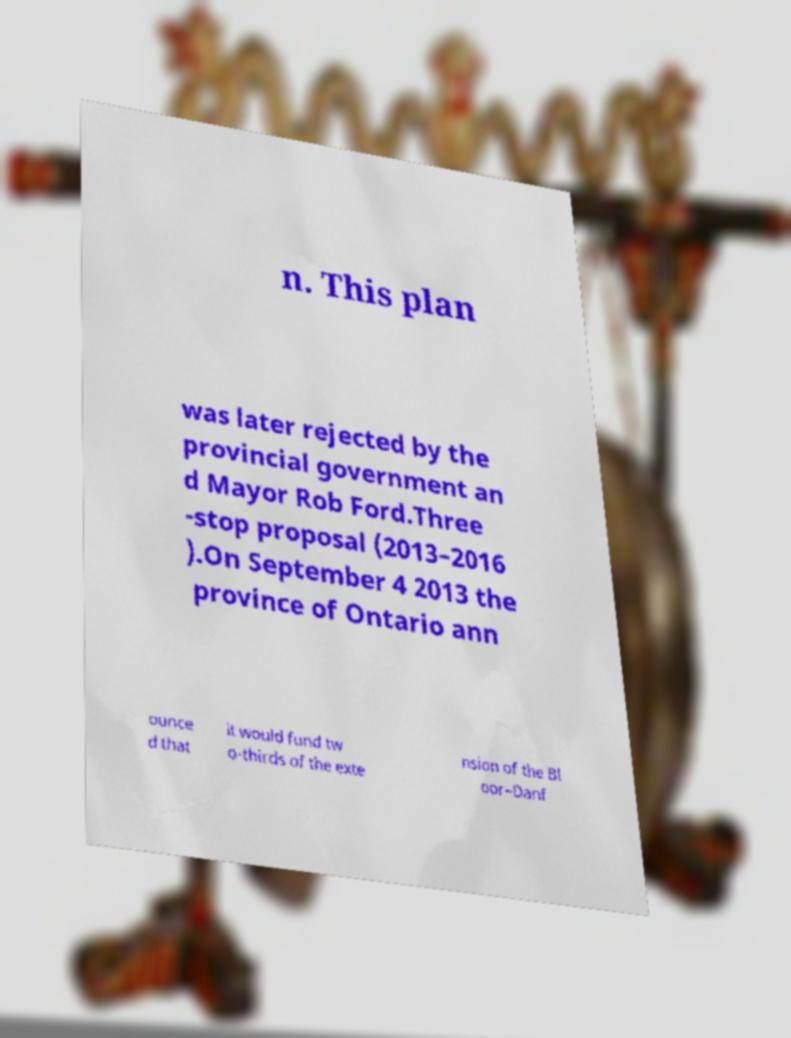What messages or text are displayed in this image? I need them in a readable, typed format. n. This plan was later rejected by the provincial government an d Mayor Rob Ford.Three -stop proposal (2013–2016 ).On September 4 2013 the province of Ontario ann ounce d that it would fund tw o-thirds of the exte nsion of the Bl oor–Danf 